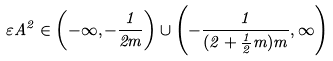Convert formula to latex. <formula><loc_0><loc_0><loc_500><loc_500>\varepsilon A ^ { 2 } \in \left ( - \infty , - \frac { 1 } { 2 m } \right ) \cup \left ( - \frac { 1 } { ( 2 + \frac { 1 } { 2 } m ) m } , \infty \right )</formula> 